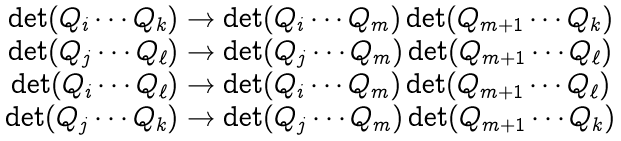<formula> <loc_0><loc_0><loc_500><loc_500>\begin{array} { c } \det ( Q _ { i } \cdots Q _ { k } ) \to \det ( Q _ { i } \cdots Q _ { m } ) \det ( Q _ { m + 1 } \cdots Q _ { k } ) \\ \det ( Q _ { j } \cdots Q _ { \ell } ) \to \det ( Q _ { j } \cdots Q _ { m } ) \det ( Q _ { m + 1 } \cdots Q _ { \ell } ) \\ \det ( Q _ { i } \cdots Q _ { \ell } ) \to \det ( Q _ { i } \cdots Q _ { m } ) \det ( Q _ { m + 1 } \cdots Q _ { \ell } ) \\ \det ( Q _ { j } \cdots Q _ { k } ) \to \det ( Q _ { j } \cdots Q _ { m } ) \det ( Q _ { m + 1 } \cdots Q _ { k } ) \end{array}</formula> 